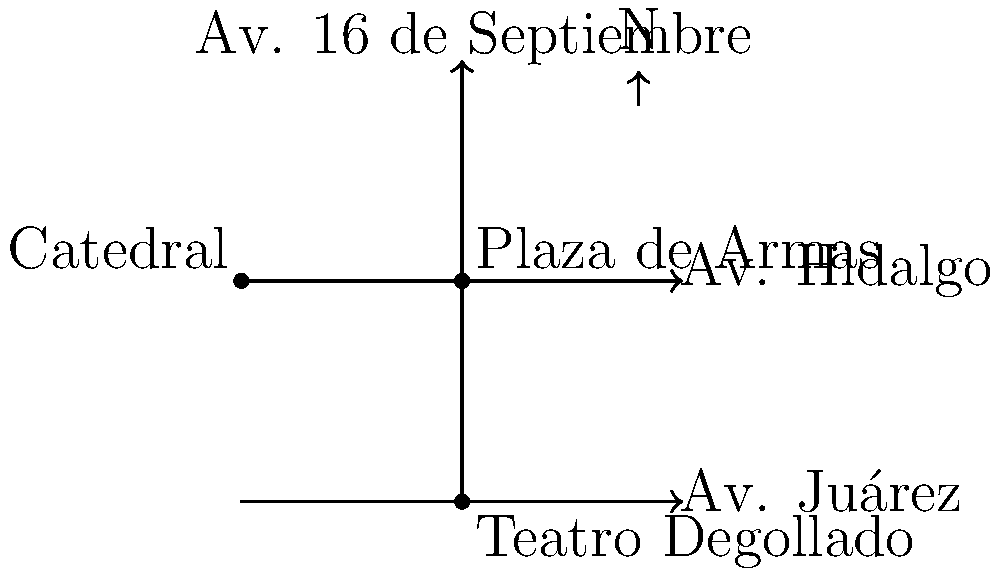Based on the simplified map of Guadalajara's historic center, which famous landmark is located at the intersection of Av. Juárez and Av. 16 de Septiembre? To answer this question, let's analyze the map step-by-step:

1. The map shows three main streets:
   - Av. Juárez (horizontal, at the bottom)
   - Av. Hidalgo (horizontal, at the top)
   - Av. 16 de Septiembre (vertical, in the center)

2. We need to identify the intersection of Av. Juárez and Av. 16 de Septiembre.
   - Av. Juárez is the bottom horizontal street
   - Av. 16 de Septiembre is the vertical street

3. Their intersection is at the bottom-center of the map.

4. At this intersection, we can see a landmark labeled "Teatro Degollado".

Therefore, the famous landmark located at the intersection of Av. Juárez and Av. 16 de Septiembre is the Teatro Degollado.
Answer: Teatro Degollado 